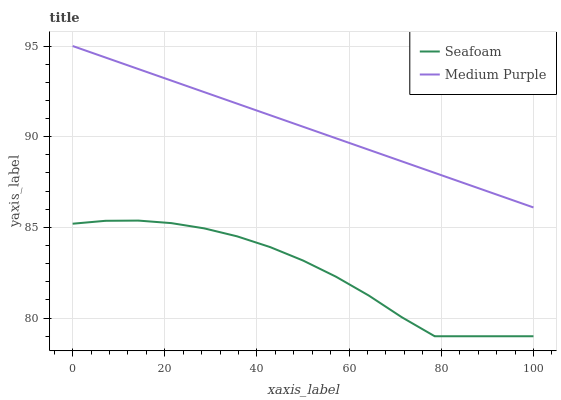Does Seafoam have the minimum area under the curve?
Answer yes or no. Yes. Does Medium Purple have the maximum area under the curve?
Answer yes or no. Yes. Does Seafoam have the maximum area under the curve?
Answer yes or no. No. Is Medium Purple the smoothest?
Answer yes or no. Yes. Is Seafoam the roughest?
Answer yes or no. Yes. Is Seafoam the smoothest?
Answer yes or no. No. Does Seafoam have the lowest value?
Answer yes or no. Yes. Does Medium Purple have the highest value?
Answer yes or no. Yes. Does Seafoam have the highest value?
Answer yes or no. No. Is Seafoam less than Medium Purple?
Answer yes or no. Yes. Is Medium Purple greater than Seafoam?
Answer yes or no. Yes. Does Seafoam intersect Medium Purple?
Answer yes or no. No. 